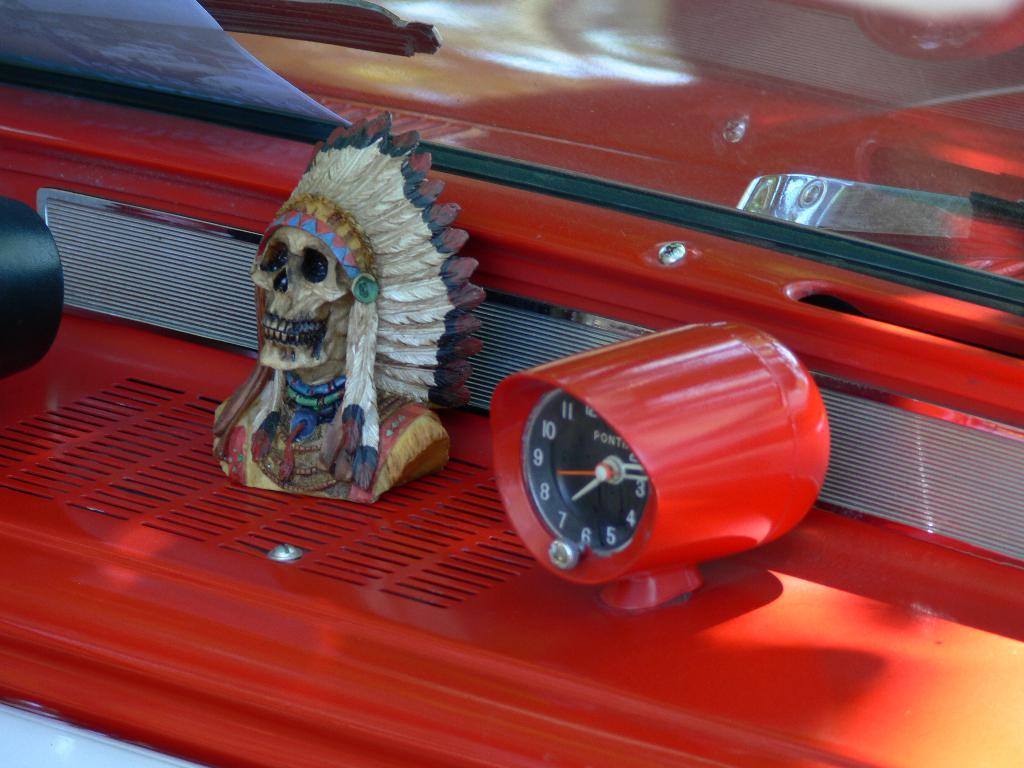What object in the image is used for measuring time? There is a clock in the image that is used for measuring time. What type of artwork can be seen in the image? There is a sculpture in the image. What is the third object mentioned in the facts? There is a paper in the image. What color is mentioned in the facts? The red color surface is present in the image. Where is the hydrant located in the image? There is no hydrant present in the image. How much sugar is in the sculpture in the image? There is no sugar mentioned or depicted in the image, as it features a clock, a sculpture, and a paper. 